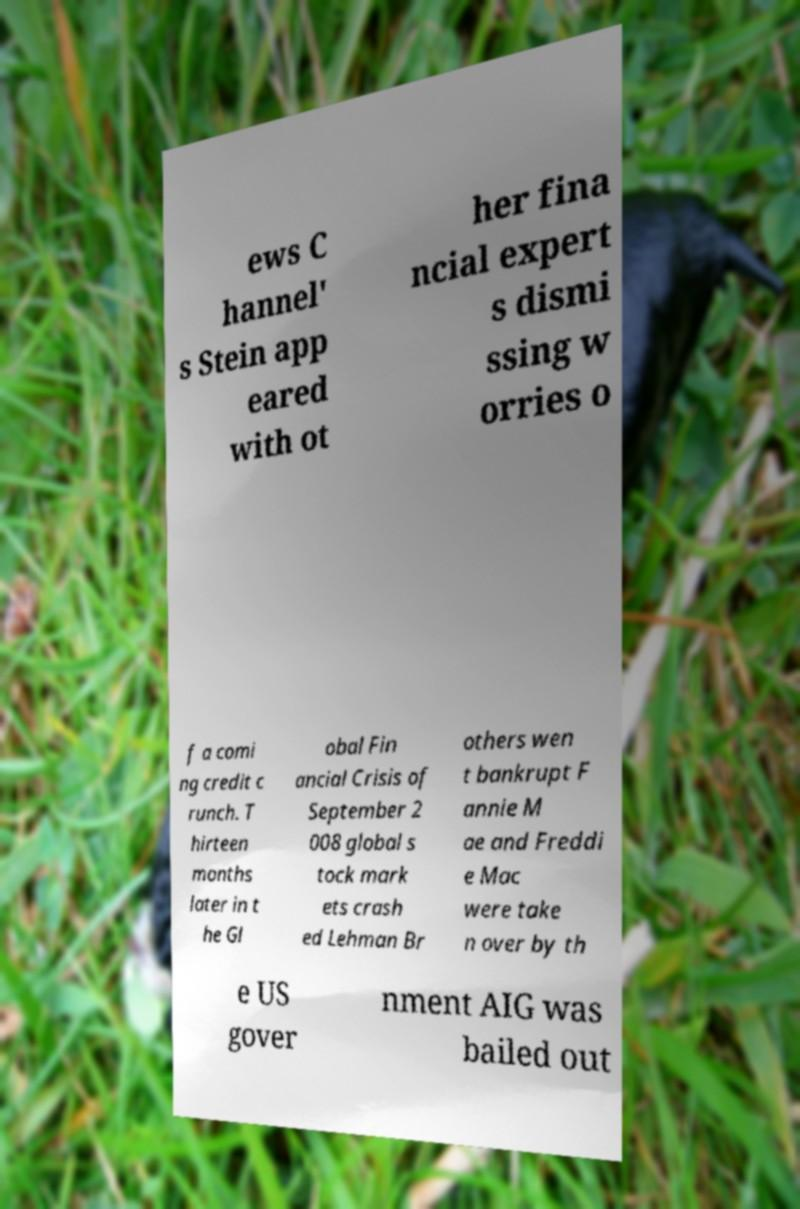What messages or text are displayed in this image? I need them in a readable, typed format. ews C hannel' s Stein app eared with ot her fina ncial expert s dismi ssing w orries o f a comi ng credit c runch. T hirteen months later in t he Gl obal Fin ancial Crisis of September 2 008 global s tock mark ets crash ed Lehman Br others wen t bankrupt F annie M ae and Freddi e Mac were take n over by th e US gover nment AIG was bailed out 